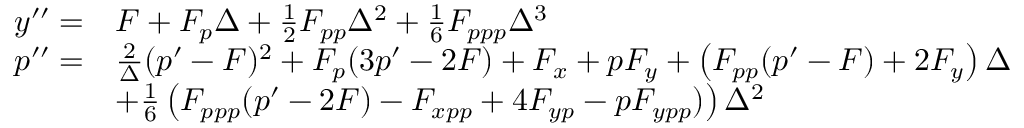<formula> <loc_0><loc_0><loc_500><loc_500>\begin{array} { r l } { y ^ { \prime \prime } = } & { F + F _ { p } \Delta + \frac { 1 } { 2 } F _ { p p } \Delta ^ { 2 } + \frac { 1 } { 6 } F _ { p p p } \Delta ^ { 3 } } \\ { p ^ { \prime \prime } = } & { \frac { 2 } { \Delta } ( p ^ { \prime } - F ) ^ { 2 } + F _ { p } ( 3 p ^ { \prime } - 2 F ) + F _ { x } + p F _ { y } + \left ( F _ { p p } ( p ^ { \prime } - F ) + 2 F _ { y } \right ) \Delta } \\ & { + \frac { 1 } { 6 } \left ( F _ { p p p } ( p ^ { \prime } - 2 F ) - F _ { x p p } + 4 F _ { y p } - p F _ { y p p } ) \right ) \Delta ^ { 2 } } \end{array}</formula> 